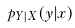<formula> <loc_0><loc_0><loc_500><loc_500>p _ { Y | X } ( y | x )</formula> 